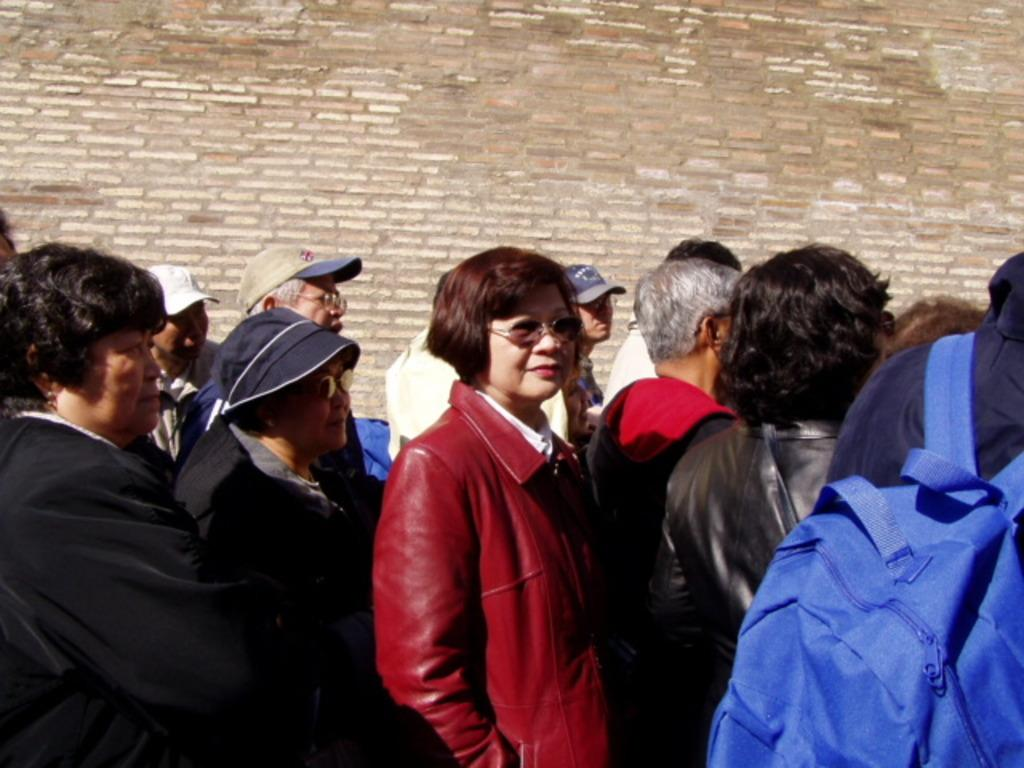How many people are in the image? There is a group of people in the image, but the exact number is not specified. What are the people doing in the image? The people are standing on a path in the image. What is visible behind the people? There is a wall visible behind the people in the image. What type of cheese is being served on the list in the image? There is no cheese or list present in the image. Who is the porter in the image? There is no porter present in the image. 